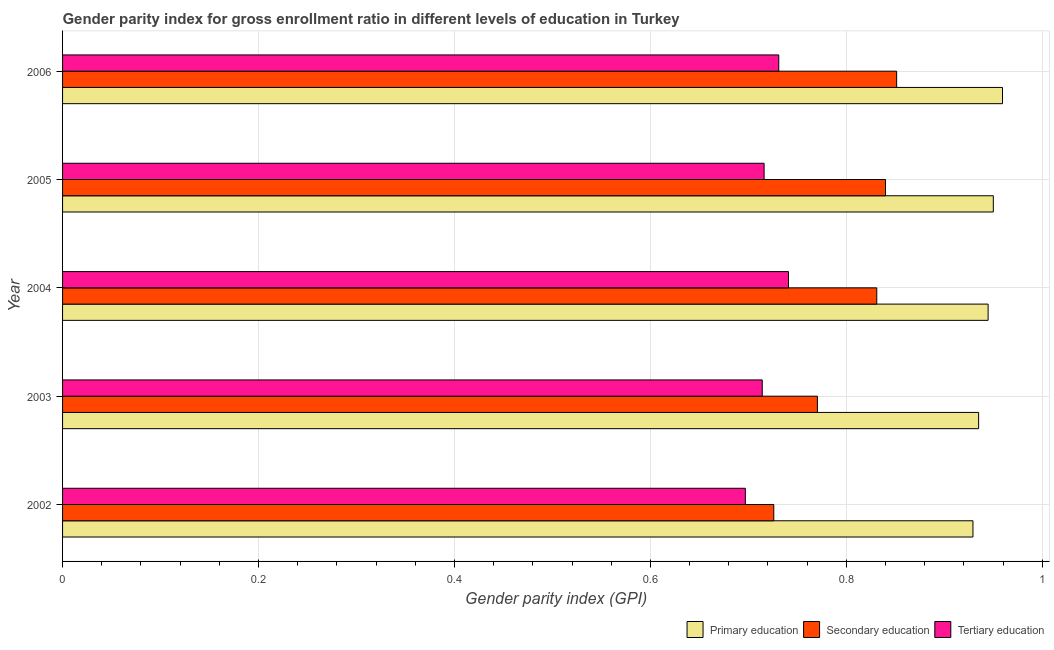How many groups of bars are there?
Make the answer very short. 5. How many bars are there on the 1st tick from the top?
Make the answer very short. 3. How many bars are there on the 5th tick from the bottom?
Your response must be concise. 3. What is the gender parity index in tertiary education in 2006?
Keep it short and to the point. 0.73. Across all years, what is the maximum gender parity index in primary education?
Your answer should be compact. 0.96. Across all years, what is the minimum gender parity index in tertiary education?
Your response must be concise. 0.7. What is the total gender parity index in primary education in the graph?
Provide a short and direct response. 4.72. What is the difference between the gender parity index in tertiary education in 2003 and that in 2004?
Ensure brevity in your answer.  -0.03. What is the difference between the gender parity index in secondary education in 2006 and the gender parity index in tertiary education in 2004?
Your answer should be compact. 0.11. What is the average gender parity index in tertiary education per year?
Your response must be concise. 0.72. In the year 2005, what is the difference between the gender parity index in primary education and gender parity index in secondary education?
Offer a very short reply. 0.11. In how many years, is the gender parity index in tertiary education greater than 0.88 ?
Offer a terse response. 0. What is the ratio of the gender parity index in primary education in 2004 to that in 2006?
Make the answer very short. 0.98. Is the gender parity index in primary education in 2002 less than that in 2004?
Provide a short and direct response. Yes. Is the difference between the gender parity index in primary education in 2002 and 2006 greater than the difference between the gender parity index in tertiary education in 2002 and 2006?
Offer a terse response. Yes. What is the difference between the highest and the second highest gender parity index in secondary education?
Make the answer very short. 0.01. What is the difference between the highest and the lowest gender parity index in secondary education?
Keep it short and to the point. 0.13. In how many years, is the gender parity index in primary education greater than the average gender parity index in primary education taken over all years?
Provide a short and direct response. 3. Is the sum of the gender parity index in secondary education in 2002 and 2006 greater than the maximum gender parity index in tertiary education across all years?
Your answer should be very brief. Yes. Is it the case that in every year, the sum of the gender parity index in primary education and gender parity index in secondary education is greater than the gender parity index in tertiary education?
Offer a terse response. Yes. How many years are there in the graph?
Your response must be concise. 5. Does the graph contain any zero values?
Provide a short and direct response. No. Where does the legend appear in the graph?
Provide a succinct answer. Bottom right. How many legend labels are there?
Provide a succinct answer. 3. What is the title of the graph?
Your answer should be compact. Gender parity index for gross enrollment ratio in different levels of education in Turkey. Does "Food" appear as one of the legend labels in the graph?
Your answer should be compact. No. What is the label or title of the X-axis?
Keep it short and to the point. Gender parity index (GPI). What is the Gender parity index (GPI) in Primary education in 2002?
Ensure brevity in your answer.  0.93. What is the Gender parity index (GPI) in Secondary education in 2002?
Keep it short and to the point. 0.73. What is the Gender parity index (GPI) of Tertiary education in 2002?
Provide a succinct answer. 0.7. What is the Gender parity index (GPI) of Primary education in 2003?
Your answer should be very brief. 0.94. What is the Gender parity index (GPI) in Secondary education in 2003?
Your answer should be very brief. 0.77. What is the Gender parity index (GPI) of Tertiary education in 2003?
Your response must be concise. 0.71. What is the Gender parity index (GPI) in Primary education in 2004?
Offer a terse response. 0.94. What is the Gender parity index (GPI) in Secondary education in 2004?
Keep it short and to the point. 0.83. What is the Gender parity index (GPI) in Tertiary education in 2004?
Your answer should be very brief. 0.74. What is the Gender parity index (GPI) in Primary education in 2005?
Provide a succinct answer. 0.95. What is the Gender parity index (GPI) of Secondary education in 2005?
Provide a short and direct response. 0.84. What is the Gender parity index (GPI) of Tertiary education in 2005?
Offer a very short reply. 0.72. What is the Gender parity index (GPI) in Primary education in 2006?
Offer a very short reply. 0.96. What is the Gender parity index (GPI) of Secondary education in 2006?
Keep it short and to the point. 0.85. What is the Gender parity index (GPI) in Tertiary education in 2006?
Your answer should be compact. 0.73. Across all years, what is the maximum Gender parity index (GPI) of Primary education?
Offer a terse response. 0.96. Across all years, what is the maximum Gender parity index (GPI) of Secondary education?
Your answer should be compact. 0.85. Across all years, what is the maximum Gender parity index (GPI) of Tertiary education?
Your answer should be compact. 0.74. Across all years, what is the minimum Gender parity index (GPI) of Primary education?
Provide a short and direct response. 0.93. Across all years, what is the minimum Gender parity index (GPI) of Secondary education?
Your answer should be compact. 0.73. Across all years, what is the minimum Gender parity index (GPI) in Tertiary education?
Your answer should be very brief. 0.7. What is the total Gender parity index (GPI) of Primary education in the graph?
Ensure brevity in your answer.  4.72. What is the total Gender parity index (GPI) of Secondary education in the graph?
Offer a terse response. 4.02. What is the total Gender parity index (GPI) in Tertiary education in the graph?
Provide a succinct answer. 3.6. What is the difference between the Gender parity index (GPI) in Primary education in 2002 and that in 2003?
Ensure brevity in your answer.  -0.01. What is the difference between the Gender parity index (GPI) of Secondary education in 2002 and that in 2003?
Your answer should be very brief. -0.04. What is the difference between the Gender parity index (GPI) in Tertiary education in 2002 and that in 2003?
Your answer should be compact. -0.02. What is the difference between the Gender parity index (GPI) in Primary education in 2002 and that in 2004?
Keep it short and to the point. -0.02. What is the difference between the Gender parity index (GPI) of Secondary education in 2002 and that in 2004?
Ensure brevity in your answer.  -0.11. What is the difference between the Gender parity index (GPI) in Tertiary education in 2002 and that in 2004?
Offer a terse response. -0.04. What is the difference between the Gender parity index (GPI) in Primary education in 2002 and that in 2005?
Provide a succinct answer. -0.02. What is the difference between the Gender parity index (GPI) of Secondary education in 2002 and that in 2005?
Your answer should be very brief. -0.11. What is the difference between the Gender parity index (GPI) of Tertiary education in 2002 and that in 2005?
Provide a succinct answer. -0.02. What is the difference between the Gender parity index (GPI) in Primary education in 2002 and that in 2006?
Your answer should be very brief. -0.03. What is the difference between the Gender parity index (GPI) of Secondary education in 2002 and that in 2006?
Give a very brief answer. -0.13. What is the difference between the Gender parity index (GPI) in Tertiary education in 2002 and that in 2006?
Give a very brief answer. -0.03. What is the difference between the Gender parity index (GPI) in Primary education in 2003 and that in 2004?
Your answer should be compact. -0.01. What is the difference between the Gender parity index (GPI) in Secondary education in 2003 and that in 2004?
Offer a terse response. -0.06. What is the difference between the Gender parity index (GPI) of Tertiary education in 2003 and that in 2004?
Ensure brevity in your answer.  -0.03. What is the difference between the Gender parity index (GPI) of Primary education in 2003 and that in 2005?
Offer a terse response. -0.01. What is the difference between the Gender parity index (GPI) in Secondary education in 2003 and that in 2005?
Provide a short and direct response. -0.07. What is the difference between the Gender parity index (GPI) of Tertiary education in 2003 and that in 2005?
Make the answer very short. -0. What is the difference between the Gender parity index (GPI) in Primary education in 2003 and that in 2006?
Provide a succinct answer. -0.02. What is the difference between the Gender parity index (GPI) of Secondary education in 2003 and that in 2006?
Provide a succinct answer. -0.08. What is the difference between the Gender parity index (GPI) in Tertiary education in 2003 and that in 2006?
Offer a terse response. -0.02. What is the difference between the Gender parity index (GPI) in Primary education in 2004 and that in 2005?
Give a very brief answer. -0.01. What is the difference between the Gender parity index (GPI) of Secondary education in 2004 and that in 2005?
Offer a terse response. -0.01. What is the difference between the Gender parity index (GPI) of Tertiary education in 2004 and that in 2005?
Keep it short and to the point. 0.02. What is the difference between the Gender parity index (GPI) in Primary education in 2004 and that in 2006?
Your answer should be very brief. -0.01. What is the difference between the Gender parity index (GPI) of Secondary education in 2004 and that in 2006?
Your response must be concise. -0.02. What is the difference between the Gender parity index (GPI) of Tertiary education in 2004 and that in 2006?
Provide a short and direct response. 0.01. What is the difference between the Gender parity index (GPI) in Primary education in 2005 and that in 2006?
Your response must be concise. -0.01. What is the difference between the Gender parity index (GPI) of Secondary education in 2005 and that in 2006?
Ensure brevity in your answer.  -0.01. What is the difference between the Gender parity index (GPI) of Tertiary education in 2005 and that in 2006?
Give a very brief answer. -0.01. What is the difference between the Gender parity index (GPI) in Primary education in 2002 and the Gender parity index (GPI) in Secondary education in 2003?
Make the answer very short. 0.16. What is the difference between the Gender parity index (GPI) in Primary education in 2002 and the Gender parity index (GPI) in Tertiary education in 2003?
Offer a very short reply. 0.22. What is the difference between the Gender parity index (GPI) in Secondary education in 2002 and the Gender parity index (GPI) in Tertiary education in 2003?
Keep it short and to the point. 0.01. What is the difference between the Gender parity index (GPI) of Primary education in 2002 and the Gender parity index (GPI) of Secondary education in 2004?
Offer a very short reply. 0.1. What is the difference between the Gender parity index (GPI) of Primary education in 2002 and the Gender parity index (GPI) of Tertiary education in 2004?
Make the answer very short. 0.19. What is the difference between the Gender parity index (GPI) in Secondary education in 2002 and the Gender parity index (GPI) in Tertiary education in 2004?
Give a very brief answer. -0.01. What is the difference between the Gender parity index (GPI) in Primary education in 2002 and the Gender parity index (GPI) in Secondary education in 2005?
Provide a succinct answer. 0.09. What is the difference between the Gender parity index (GPI) of Primary education in 2002 and the Gender parity index (GPI) of Tertiary education in 2005?
Offer a very short reply. 0.21. What is the difference between the Gender parity index (GPI) of Secondary education in 2002 and the Gender parity index (GPI) of Tertiary education in 2005?
Keep it short and to the point. 0.01. What is the difference between the Gender parity index (GPI) in Primary education in 2002 and the Gender parity index (GPI) in Secondary education in 2006?
Your answer should be compact. 0.08. What is the difference between the Gender parity index (GPI) in Primary education in 2002 and the Gender parity index (GPI) in Tertiary education in 2006?
Offer a very short reply. 0.2. What is the difference between the Gender parity index (GPI) in Secondary education in 2002 and the Gender parity index (GPI) in Tertiary education in 2006?
Offer a terse response. -0.01. What is the difference between the Gender parity index (GPI) of Primary education in 2003 and the Gender parity index (GPI) of Secondary education in 2004?
Your answer should be compact. 0.1. What is the difference between the Gender parity index (GPI) of Primary education in 2003 and the Gender parity index (GPI) of Tertiary education in 2004?
Ensure brevity in your answer.  0.19. What is the difference between the Gender parity index (GPI) of Secondary education in 2003 and the Gender parity index (GPI) of Tertiary education in 2004?
Your answer should be compact. 0.03. What is the difference between the Gender parity index (GPI) in Primary education in 2003 and the Gender parity index (GPI) in Secondary education in 2005?
Provide a short and direct response. 0.1. What is the difference between the Gender parity index (GPI) of Primary education in 2003 and the Gender parity index (GPI) of Tertiary education in 2005?
Your answer should be very brief. 0.22. What is the difference between the Gender parity index (GPI) in Secondary education in 2003 and the Gender parity index (GPI) in Tertiary education in 2005?
Provide a succinct answer. 0.05. What is the difference between the Gender parity index (GPI) in Primary education in 2003 and the Gender parity index (GPI) in Secondary education in 2006?
Your answer should be compact. 0.08. What is the difference between the Gender parity index (GPI) in Primary education in 2003 and the Gender parity index (GPI) in Tertiary education in 2006?
Your response must be concise. 0.2. What is the difference between the Gender parity index (GPI) of Secondary education in 2003 and the Gender parity index (GPI) of Tertiary education in 2006?
Give a very brief answer. 0.04. What is the difference between the Gender parity index (GPI) of Primary education in 2004 and the Gender parity index (GPI) of Secondary education in 2005?
Ensure brevity in your answer.  0.1. What is the difference between the Gender parity index (GPI) of Primary education in 2004 and the Gender parity index (GPI) of Tertiary education in 2005?
Offer a very short reply. 0.23. What is the difference between the Gender parity index (GPI) of Secondary education in 2004 and the Gender parity index (GPI) of Tertiary education in 2005?
Your response must be concise. 0.12. What is the difference between the Gender parity index (GPI) in Primary education in 2004 and the Gender parity index (GPI) in Secondary education in 2006?
Keep it short and to the point. 0.09. What is the difference between the Gender parity index (GPI) of Primary education in 2004 and the Gender parity index (GPI) of Tertiary education in 2006?
Offer a terse response. 0.21. What is the difference between the Gender parity index (GPI) in Secondary education in 2004 and the Gender parity index (GPI) in Tertiary education in 2006?
Give a very brief answer. 0.1. What is the difference between the Gender parity index (GPI) of Primary education in 2005 and the Gender parity index (GPI) of Secondary education in 2006?
Provide a succinct answer. 0.1. What is the difference between the Gender parity index (GPI) of Primary education in 2005 and the Gender parity index (GPI) of Tertiary education in 2006?
Keep it short and to the point. 0.22. What is the difference between the Gender parity index (GPI) in Secondary education in 2005 and the Gender parity index (GPI) in Tertiary education in 2006?
Offer a terse response. 0.11. What is the average Gender parity index (GPI) in Primary education per year?
Provide a short and direct response. 0.94. What is the average Gender parity index (GPI) of Secondary education per year?
Provide a short and direct response. 0.8. What is the average Gender parity index (GPI) in Tertiary education per year?
Provide a succinct answer. 0.72. In the year 2002, what is the difference between the Gender parity index (GPI) in Primary education and Gender parity index (GPI) in Secondary education?
Keep it short and to the point. 0.2. In the year 2002, what is the difference between the Gender parity index (GPI) of Primary education and Gender parity index (GPI) of Tertiary education?
Offer a very short reply. 0.23. In the year 2002, what is the difference between the Gender parity index (GPI) of Secondary education and Gender parity index (GPI) of Tertiary education?
Offer a terse response. 0.03. In the year 2003, what is the difference between the Gender parity index (GPI) of Primary education and Gender parity index (GPI) of Secondary education?
Give a very brief answer. 0.16. In the year 2003, what is the difference between the Gender parity index (GPI) in Primary education and Gender parity index (GPI) in Tertiary education?
Ensure brevity in your answer.  0.22. In the year 2003, what is the difference between the Gender parity index (GPI) in Secondary education and Gender parity index (GPI) in Tertiary education?
Your answer should be compact. 0.06. In the year 2004, what is the difference between the Gender parity index (GPI) of Primary education and Gender parity index (GPI) of Secondary education?
Give a very brief answer. 0.11. In the year 2004, what is the difference between the Gender parity index (GPI) of Primary education and Gender parity index (GPI) of Tertiary education?
Keep it short and to the point. 0.2. In the year 2004, what is the difference between the Gender parity index (GPI) in Secondary education and Gender parity index (GPI) in Tertiary education?
Ensure brevity in your answer.  0.09. In the year 2005, what is the difference between the Gender parity index (GPI) in Primary education and Gender parity index (GPI) in Secondary education?
Provide a succinct answer. 0.11. In the year 2005, what is the difference between the Gender parity index (GPI) of Primary education and Gender parity index (GPI) of Tertiary education?
Ensure brevity in your answer.  0.23. In the year 2005, what is the difference between the Gender parity index (GPI) in Secondary education and Gender parity index (GPI) in Tertiary education?
Offer a very short reply. 0.12. In the year 2006, what is the difference between the Gender parity index (GPI) in Primary education and Gender parity index (GPI) in Secondary education?
Keep it short and to the point. 0.11. In the year 2006, what is the difference between the Gender parity index (GPI) of Primary education and Gender parity index (GPI) of Tertiary education?
Your response must be concise. 0.23. In the year 2006, what is the difference between the Gender parity index (GPI) of Secondary education and Gender parity index (GPI) of Tertiary education?
Offer a very short reply. 0.12. What is the ratio of the Gender parity index (GPI) in Primary education in 2002 to that in 2003?
Offer a terse response. 0.99. What is the ratio of the Gender parity index (GPI) in Secondary education in 2002 to that in 2003?
Provide a short and direct response. 0.94. What is the ratio of the Gender parity index (GPI) in Tertiary education in 2002 to that in 2003?
Your answer should be compact. 0.98. What is the ratio of the Gender parity index (GPI) in Primary education in 2002 to that in 2004?
Your answer should be very brief. 0.98. What is the ratio of the Gender parity index (GPI) in Secondary education in 2002 to that in 2004?
Provide a short and direct response. 0.87. What is the ratio of the Gender parity index (GPI) in Tertiary education in 2002 to that in 2004?
Ensure brevity in your answer.  0.94. What is the ratio of the Gender parity index (GPI) in Primary education in 2002 to that in 2005?
Your answer should be compact. 0.98. What is the ratio of the Gender parity index (GPI) of Secondary education in 2002 to that in 2005?
Provide a succinct answer. 0.86. What is the ratio of the Gender parity index (GPI) of Tertiary education in 2002 to that in 2005?
Keep it short and to the point. 0.97. What is the ratio of the Gender parity index (GPI) in Primary education in 2002 to that in 2006?
Offer a terse response. 0.97. What is the ratio of the Gender parity index (GPI) in Secondary education in 2002 to that in 2006?
Make the answer very short. 0.85. What is the ratio of the Gender parity index (GPI) of Tertiary education in 2002 to that in 2006?
Make the answer very short. 0.95. What is the ratio of the Gender parity index (GPI) of Primary education in 2003 to that in 2004?
Offer a very short reply. 0.99. What is the ratio of the Gender parity index (GPI) in Secondary education in 2003 to that in 2004?
Offer a terse response. 0.93. What is the ratio of the Gender parity index (GPI) in Tertiary education in 2003 to that in 2004?
Provide a succinct answer. 0.96. What is the ratio of the Gender parity index (GPI) of Primary education in 2003 to that in 2005?
Make the answer very short. 0.98. What is the ratio of the Gender parity index (GPI) in Secondary education in 2003 to that in 2005?
Your response must be concise. 0.92. What is the ratio of the Gender parity index (GPI) in Tertiary education in 2003 to that in 2005?
Keep it short and to the point. 1. What is the ratio of the Gender parity index (GPI) in Primary education in 2003 to that in 2006?
Keep it short and to the point. 0.97. What is the ratio of the Gender parity index (GPI) in Secondary education in 2003 to that in 2006?
Provide a succinct answer. 0.91. What is the ratio of the Gender parity index (GPI) of Tertiary education in 2003 to that in 2006?
Provide a succinct answer. 0.98. What is the ratio of the Gender parity index (GPI) in Tertiary education in 2004 to that in 2005?
Your answer should be compact. 1.03. What is the ratio of the Gender parity index (GPI) in Primary education in 2004 to that in 2006?
Your response must be concise. 0.98. What is the ratio of the Gender parity index (GPI) of Secondary education in 2004 to that in 2006?
Ensure brevity in your answer.  0.98. What is the ratio of the Gender parity index (GPI) in Tertiary education in 2004 to that in 2006?
Provide a succinct answer. 1.01. What is the ratio of the Gender parity index (GPI) in Primary education in 2005 to that in 2006?
Your answer should be compact. 0.99. What is the ratio of the Gender parity index (GPI) of Secondary education in 2005 to that in 2006?
Keep it short and to the point. 0.99. What is the ratio of the Gender parity index (GPI) in Tertiary education in 2005 to that in 2006?
Your response must be concise. 0.98. What is the difference between the highest and the second highest Gender parity index (GPI) of Primary education?
Offer a terse response. 0.01. What is the difference between the highest and the second highest Gender parity index (GPI) of Secondary education?
Provide a succinct answer. 0.01. What is the difference between the highest and the second highest Gender parity index (GPI) in Tertiary education?
Ensure brevity in your answer.  0.01. What is the difference between the highest and the lowest Gender parity index (GPI) in Primary education?
Offer a very short reply. 0.03. What is the difference between the highest and the lowest Gender parity index (GPI) of Secondary education?
Provide a short and direct response. 0.13. What is the difference between the highest and the lowest Gender parity index (GPI) in Tertiary education?
Provide a short and direct response. 0.04. 